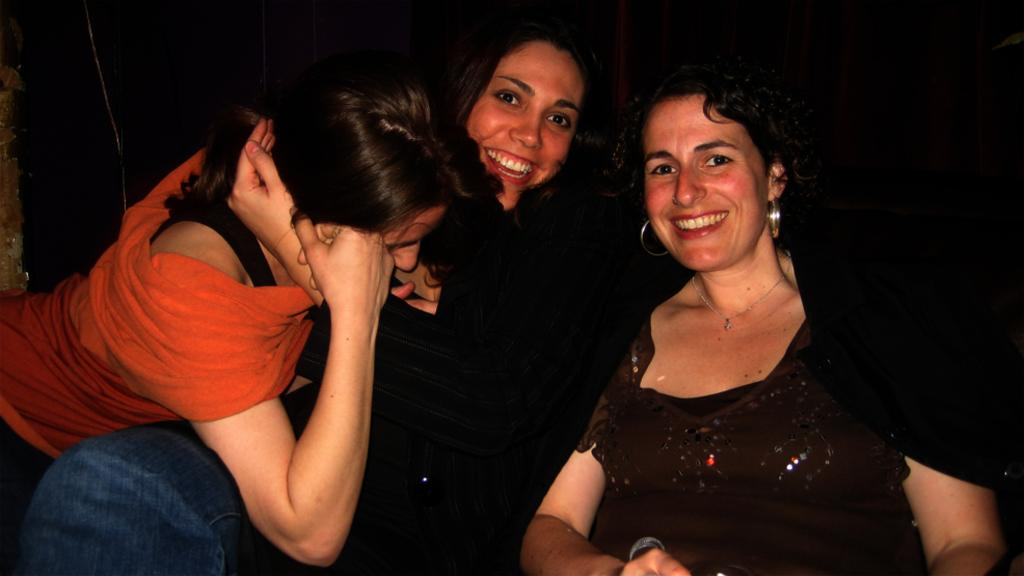How many people are in the image? There are three women in the image. What are the women doing in the image? The women are sitting. Can you describe the background of the image? The background of the image is dark. What type of rabbit can be seen shaking its tail in the image? There is no rabbit present in the image, and therefore no such activity can be observed. 